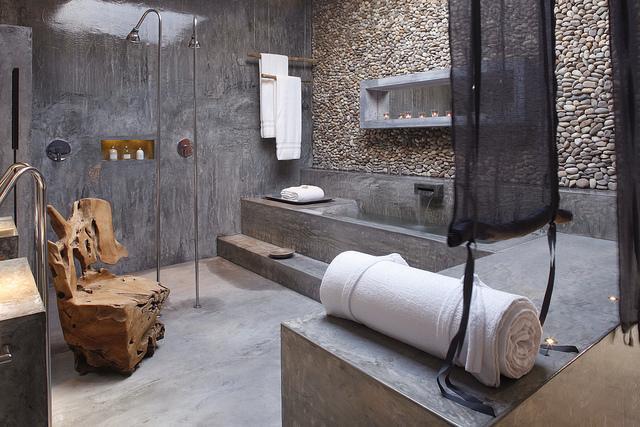How many towels are hanging on the wall?
Give a very brief answer. 2. How many people are shown?
Give a very brief answer. 0. 